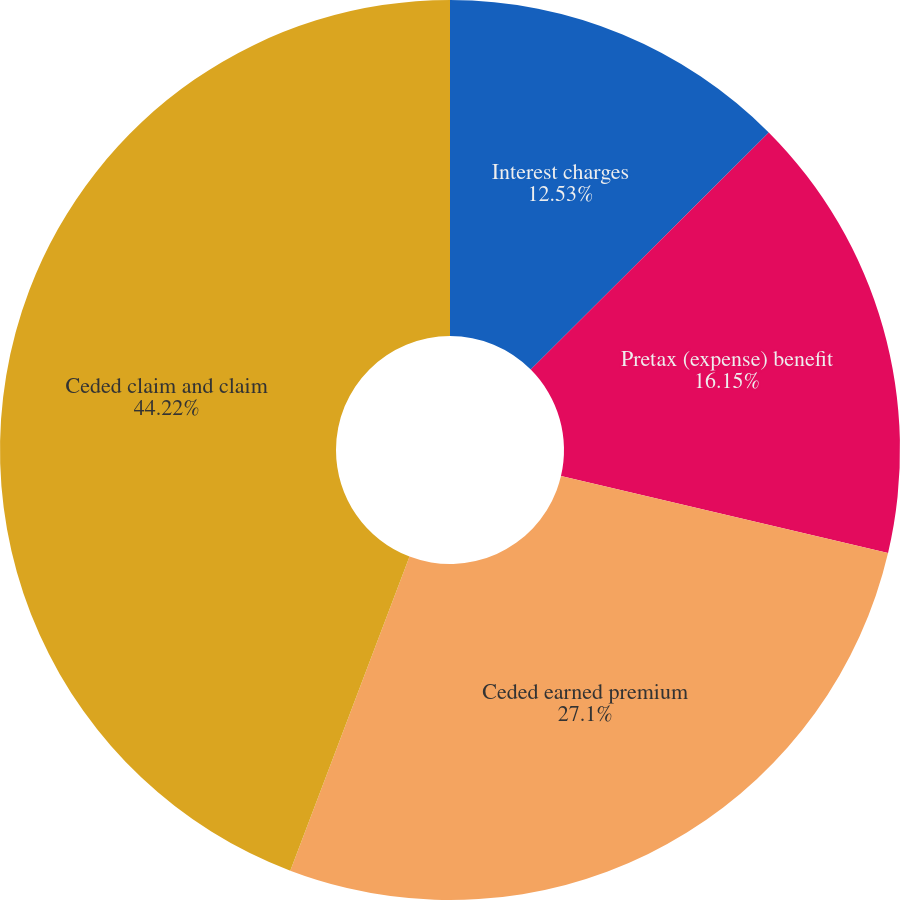<chart> <loc_0><loc_0><loc_500><loc_500><pie_chart><fcel>Interest charges<fcel>Pretax (expense) benefit<fcel>Ceded earned premium<fcel>Ceded claim and claim<nl><fcel>12.53%<fcel>16.15%<fcel>27.1%<fcel>44.23%<nl></chart> 